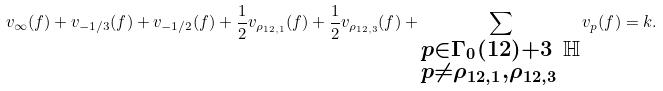<formula> <loc_0><loc_0><loc_500><loc_500>v _ { \infty } ( f ) + v _ { - 1 / 3 } ( f ) + v _ { - 1 / 2 } ( f ) + \frac { 1 } { 2 } v _ { \rho _ { 1 2 , 1 } } ( f ) + \frac { 1 } { 2 } v _ { \rho _ { 1 2 , 3 } } ( f ) + \sum _ { \begin{subarray} { c } p \in \Gamma _ { 0 } ( 1 2 ) + 3 \ \mathbb { H } \\ p \ne \rho _ { 1 2 , 1 } , \rho _ { 1 2 , 3 } \end{subarray} } v _ { p } ( f ) = k .</formula> 